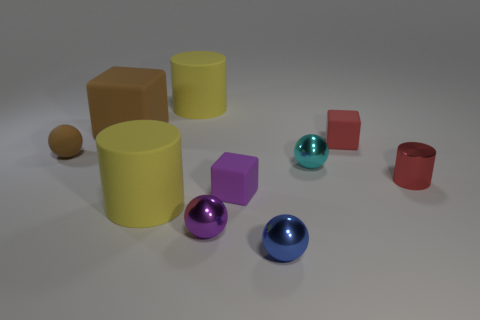Can you describe the textures of the objects in the scene? The scene includes a variety of textures. The two cylinders and the sphere demonstrate a shiny, smooth surface, likely metal or plastic. The cubes and other blocks appear to have a matte, non-reflective texture suggesting a more absorbent material, possibly wood or a matte-finish plastic. 